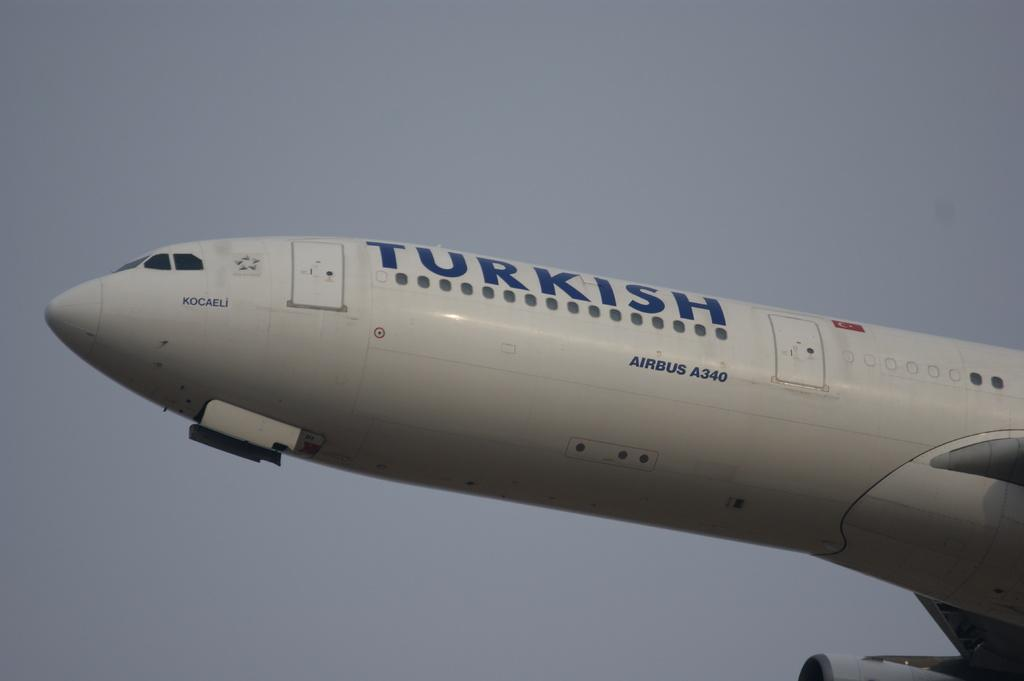<image>
Offer a succinct explanation of the picture presented. the word Turkish is on the side of a plane 